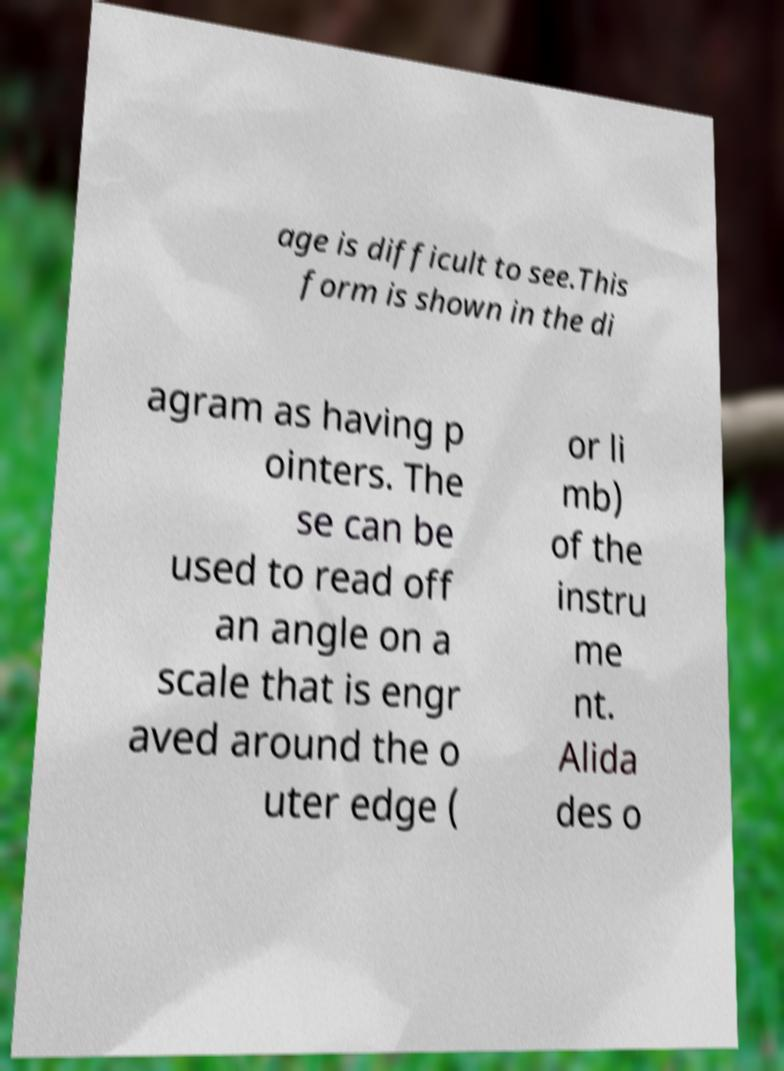Can you accurately transcribe the text from the provided image for me? age is difficult to see.This form is shown in the di agram as having p ointers. The se can be used to read off an angle on a scale that is engr aved around the o uter edge ( or li mb) of the instru me nt. Alida des o 